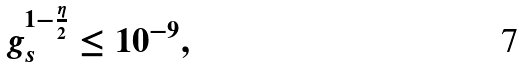<formula> <loc_0><loc_0><loc_500><loc_500>g _ { s } ^ { 1 - \frac { \eta } { 2 } } \leq 1 0 ^ { - 9 } ,</formula> 